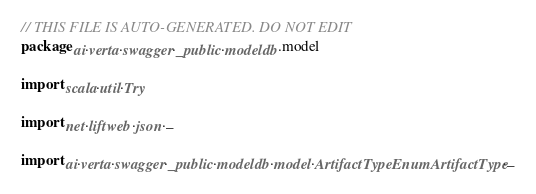Convert code to text. <code><loc_0><loc_0><loc_500><loc_500><_Scala_>// THIS FILE IS AUTO-GENERATED. DO NOT EDIT
package ai.verta.swagger._public.modeldb.model

import scala.util.Try

import net.liftweb.json._

import ai.verta.swagger._public.modeldb.model.ArtifactTypeEnumArtifactType._</code> 